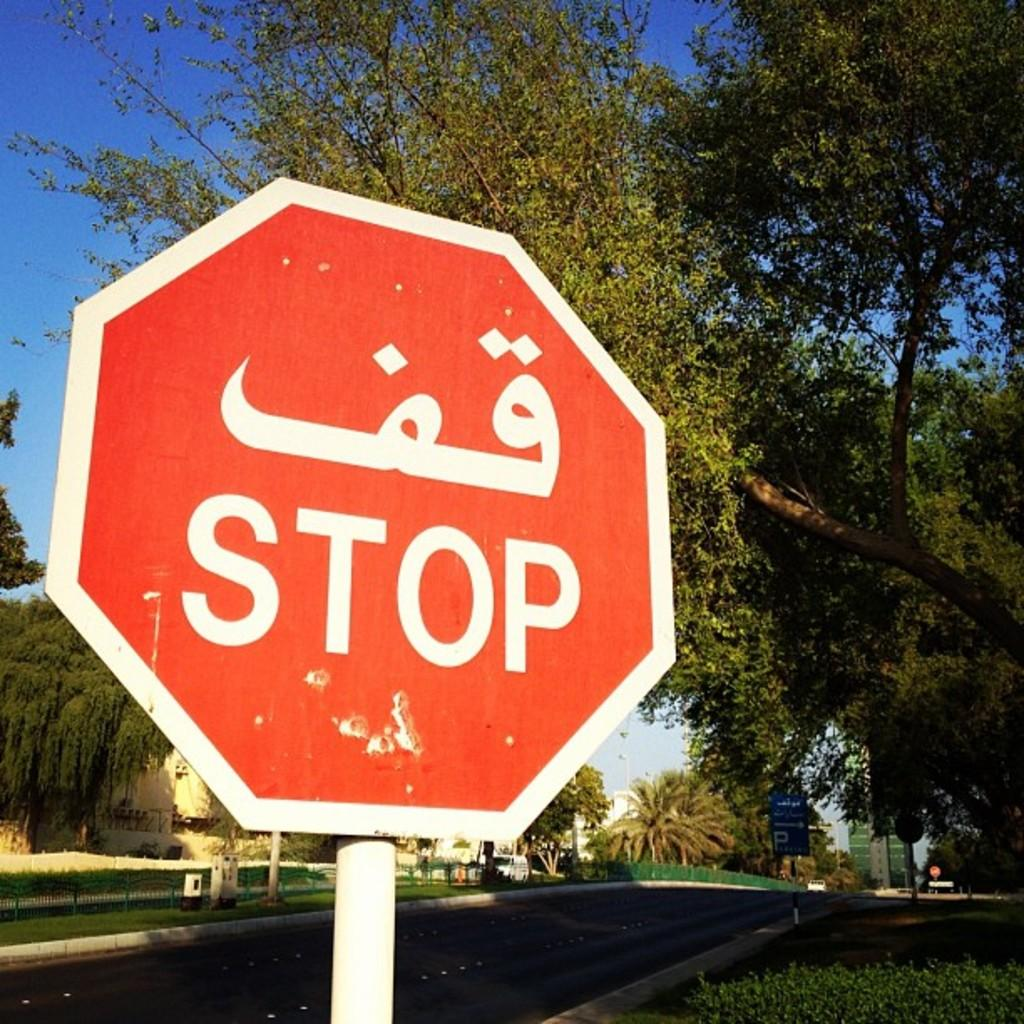<image>
Create a compact narrative representing the image presented. a stop sign that is outside on a pole 